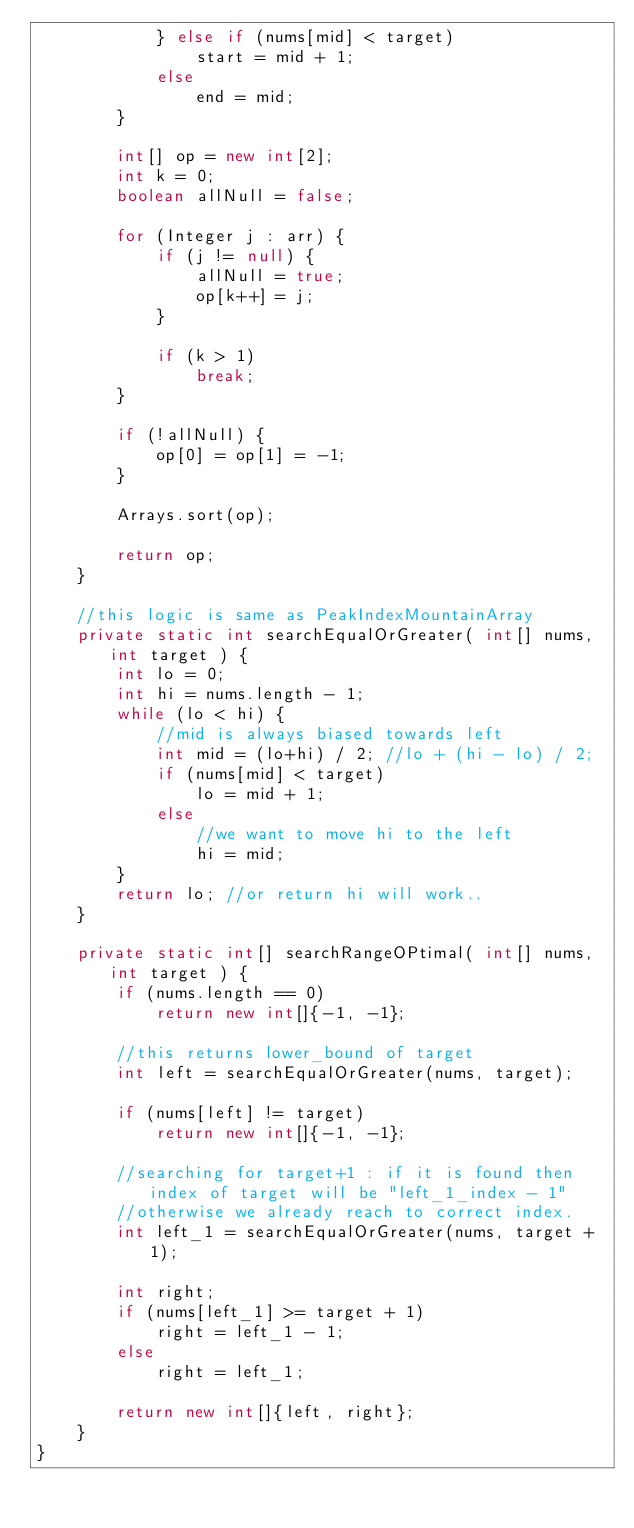Convert code to text. <code><loc_0><loc_0><loc_500><loc_500><_Java_>            } else if (nums[mid] < target)
                start = mid + 1;
            else
                end = mid;
        }

        int[] op = new int[2];
        int k = 0;
        boolean allNull = false;

        for (Integer j : arr) {
            if (j != null) {
                allNull = true;
                op[k++] = j;
            }

            if (k > 1)
                break;
        }

        if (!allNull) {
            op[0] = op[1] = -1;
        }

        Arrays.sort(op);

        return op;
    }

    //this logic is same as PeakIndexMountainArray
    private static int searchEqualOrGreater( int[] nums, int target ) {
        int lo = 0;
        int hi = nums.length - 1;
        while (lo < hi) {
            //mid is always biased towards left
            int mid = (lo+hi) / 2; //lo + (hi - lo) / 2;
            if (nums[mid] < target)
                lo = mid + 1;
            else
                //we want to move hi to the left
                hi = mid;
        }
        return lo; //or return hi will work..
    }

    private static int[] searchRangeOPtimal( int[] nums, int target ) {
        if (nums.length == 0)
            return new int[]{-1, -1};

        //this returns lower_bound of target
        int left = searchEqualOrGreater(nums, target);

        if (nums[left] != target)
            return new int[]{-1, -1};

        //searching for target+1 : if it is found then index of target will be "left_1_index - 1"
        //otherwise we already reach to correct index.
        int left_1 = searchEqualOrGreater(nums, target + 1);

        int right;
        if (nums[left_1] >= target + 1)
            right = left_1 - 1;
        else
            right = left_1;

        return new int[]{left, right};
    }
}
</code> 